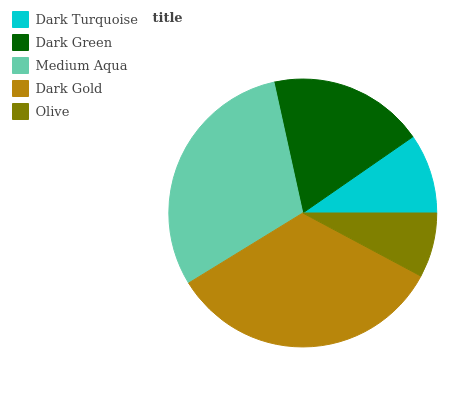Is Olive the minimum?
Answer yes or no. Yes. Is Dark Gold the maximum?
Answer yes or no. Yes. Is Dark Green the minimum?
Answer yes or no. No. Is Dark Green the maximum?
Answer yes or no. No. Is Dark Green greater than Dark Turquoise?
Answer yes or no. Yes. Is Dark Turquoise less than Dark Green?
Answer yes or no. Yes. Is Dark Turquoise greater than Dark Green?
Answer yes or no. No. Is Dark Green less than Dark Turquoise?
Answer yes or no. No. Is Dark Green the high median?
Answer yes or no. Yes. Is Dark Green the low median?
Answer yes or no. Yes. Is Medium Aqua the high median?
Answer yes or no. No. Is Olive the low median?
Answer yes or no. No. 